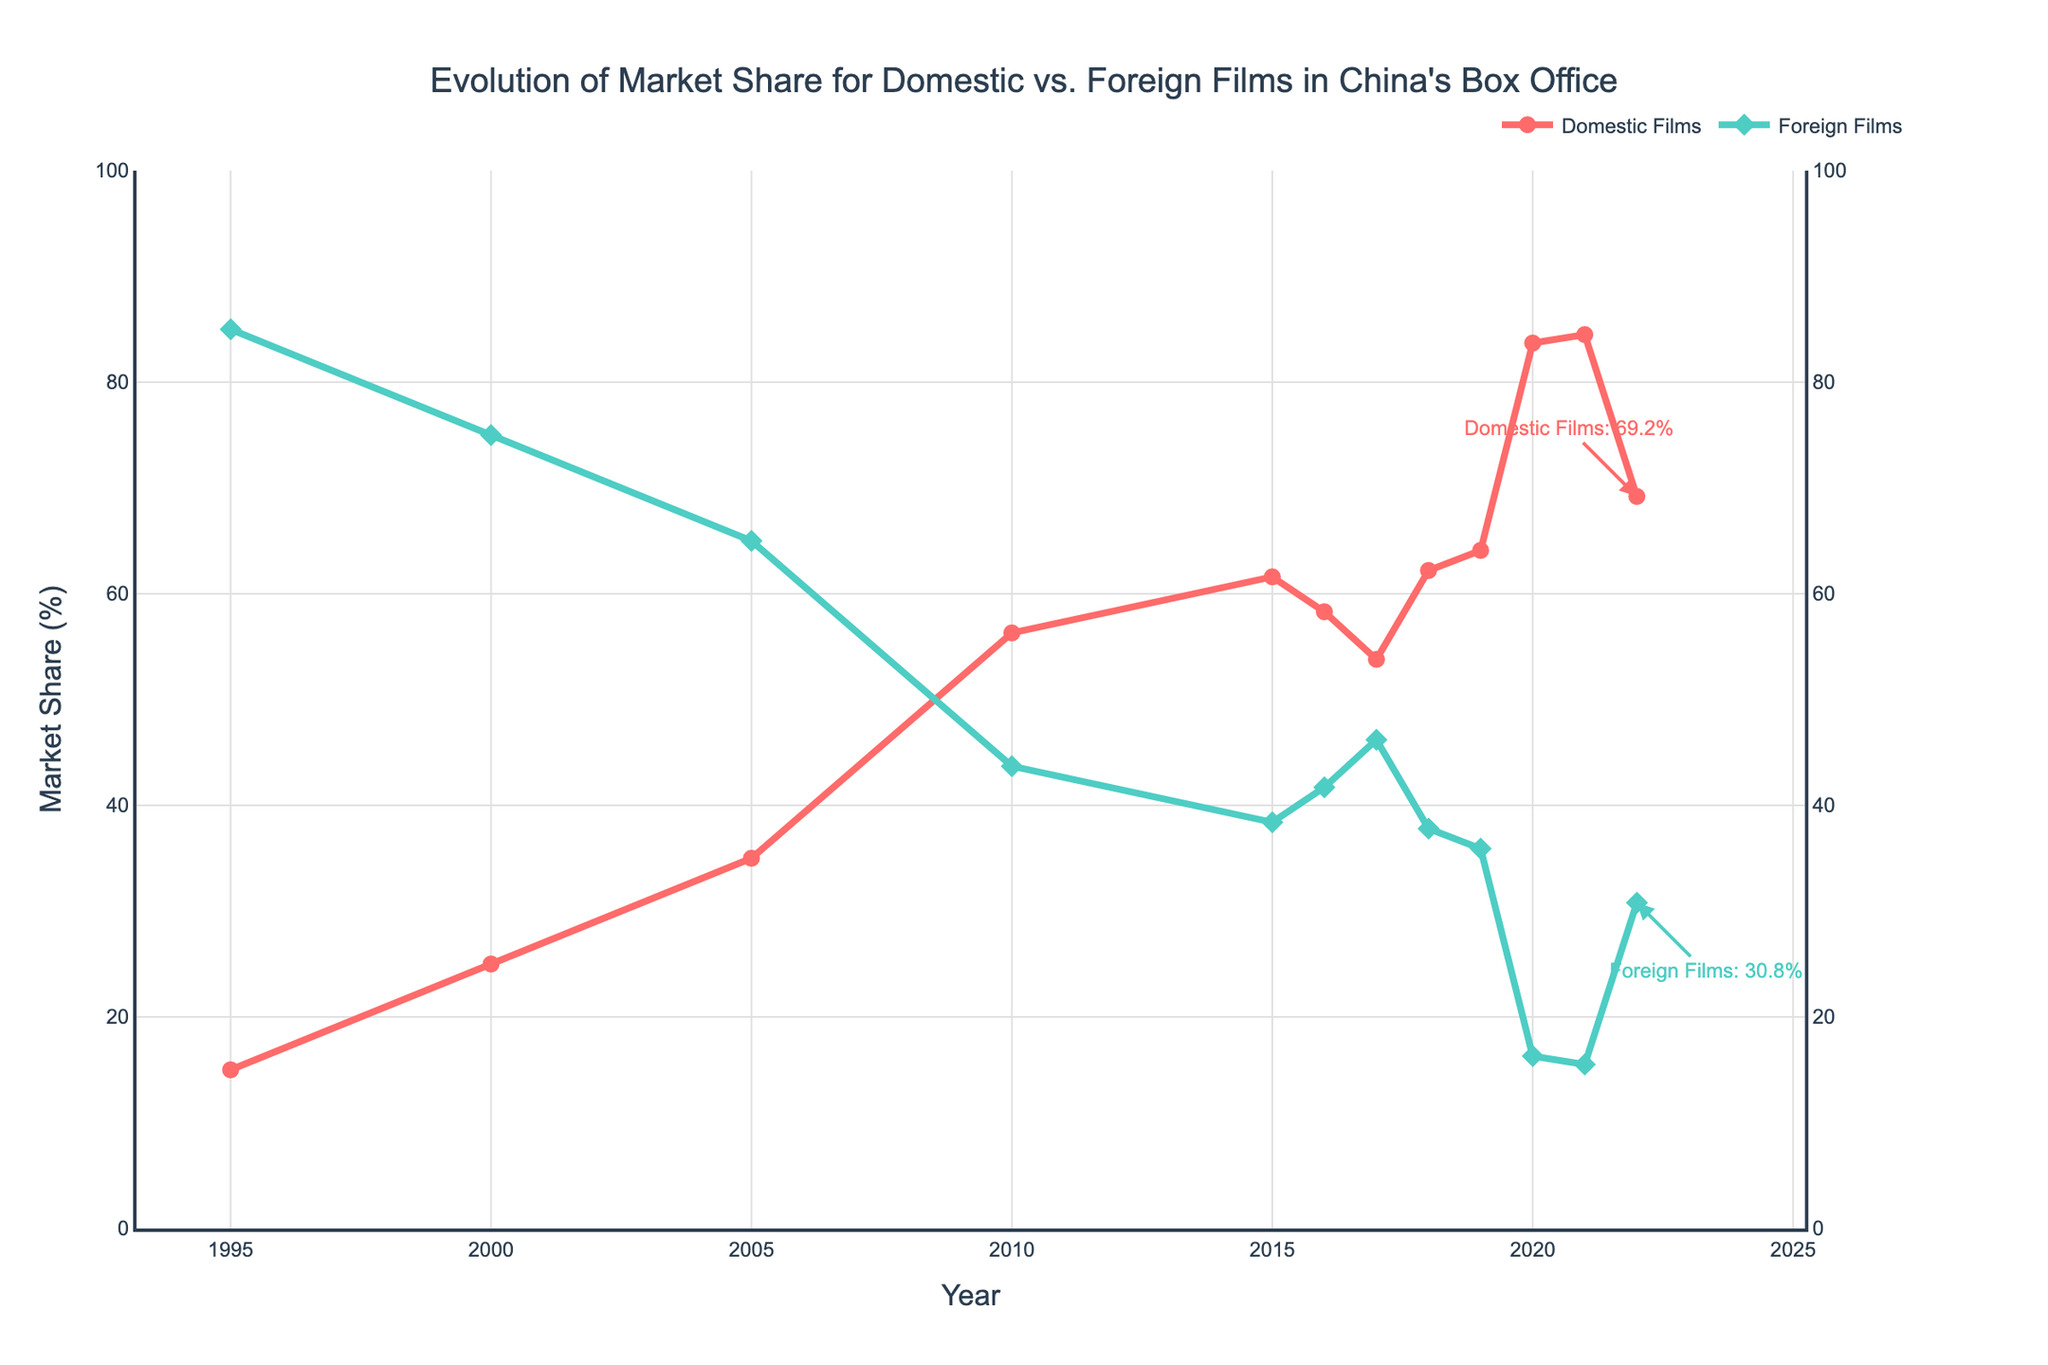What is the market share for domestic films in 2021? To find the market share for domestic films in 2021, locate the year 2021 on the x-axis and identify the corresponding value on the y-axis for the 'Domestic Films' line. The value is marked at the 84.5% point.
Answer: 84.5% How did the market share for foreign films change from 2019 to 2020? Locate the market share for foreign films in 2019 and 2020 on the y-axis. For 2019, the value is 35.9%, and for 2020, it is 16.3%. The change is a decrease of 35.9% - 16.3% = 19.6%.
Answer: Decreased by 19.6% Which year had the highest market share for domestic films? Scan the 'Domestic Films' line across all years to find the highest point. The highest market share is in 2021, where it reaches 84.5%.
Answer: 2021 How does the market share for foreign films in 2022 compare to that in 2010? Compare the market share values for foreign films in 2022 and 2010. In 2010, the market share is 43.7%, while in 2022, it is 30.8%. This shows a decrease from 2010 to 2022 by 43.7% - 30.8% = 12.9%.
Answer: Decreased by 12.9% Which year had a nearly equal market share between domestic and foreign films? Identify the year where the market shares for domestic and foreign films are close to 50% each. In 2017, the domestic films had a market share of 53.8% and foreign films had 46.2%, which is the closest to equal.
Answer: 2017 What is the trend in the market share for domestic films from 1995 to 2022? Analyze the 'Domestic Films' line from 1995 to 2022 to see if it generally increases, decreases, or fluctuates. The line shows a general increasing trend with some fluctuations.
Answer: Increasing trend How much did the market share for domestic films increase from 2005 to 2010? Find the market shares for domestic films in 2005 and 2010. In 2005, it is 35%, and in 2010, it is 56.3%. The increase is 56.3% - 35% = 21.3%.
Answer: Increased by 21.3% What visual cues indicate the market shares of domestic and foreign films in 2022? Look at the annotations and marker shapes on the graph for 2022. The red circle marker indicates the domestic films' share at 69.2%, and the green diamond marker shows the foreign films' share at 30.8%.
Answer: Markers and annotations What was the average market share for foreign films from 2015 to 2020? Sum the market shares for foreign films from 2015 to 2020 (38.4% in 2015, 41.7% in 2016, 46.2% in 2017, 37.8% in 2018, 35.9% in 2019, 16.3% in 2020) and divide by the number of years (6). The sum is (38.4 + 41.7 + 46.2 + 37.8 + 35.9 + 16.3) = 216.3. The average is 216.3 / 6 = 36.05%.
Answer: 36.05% 